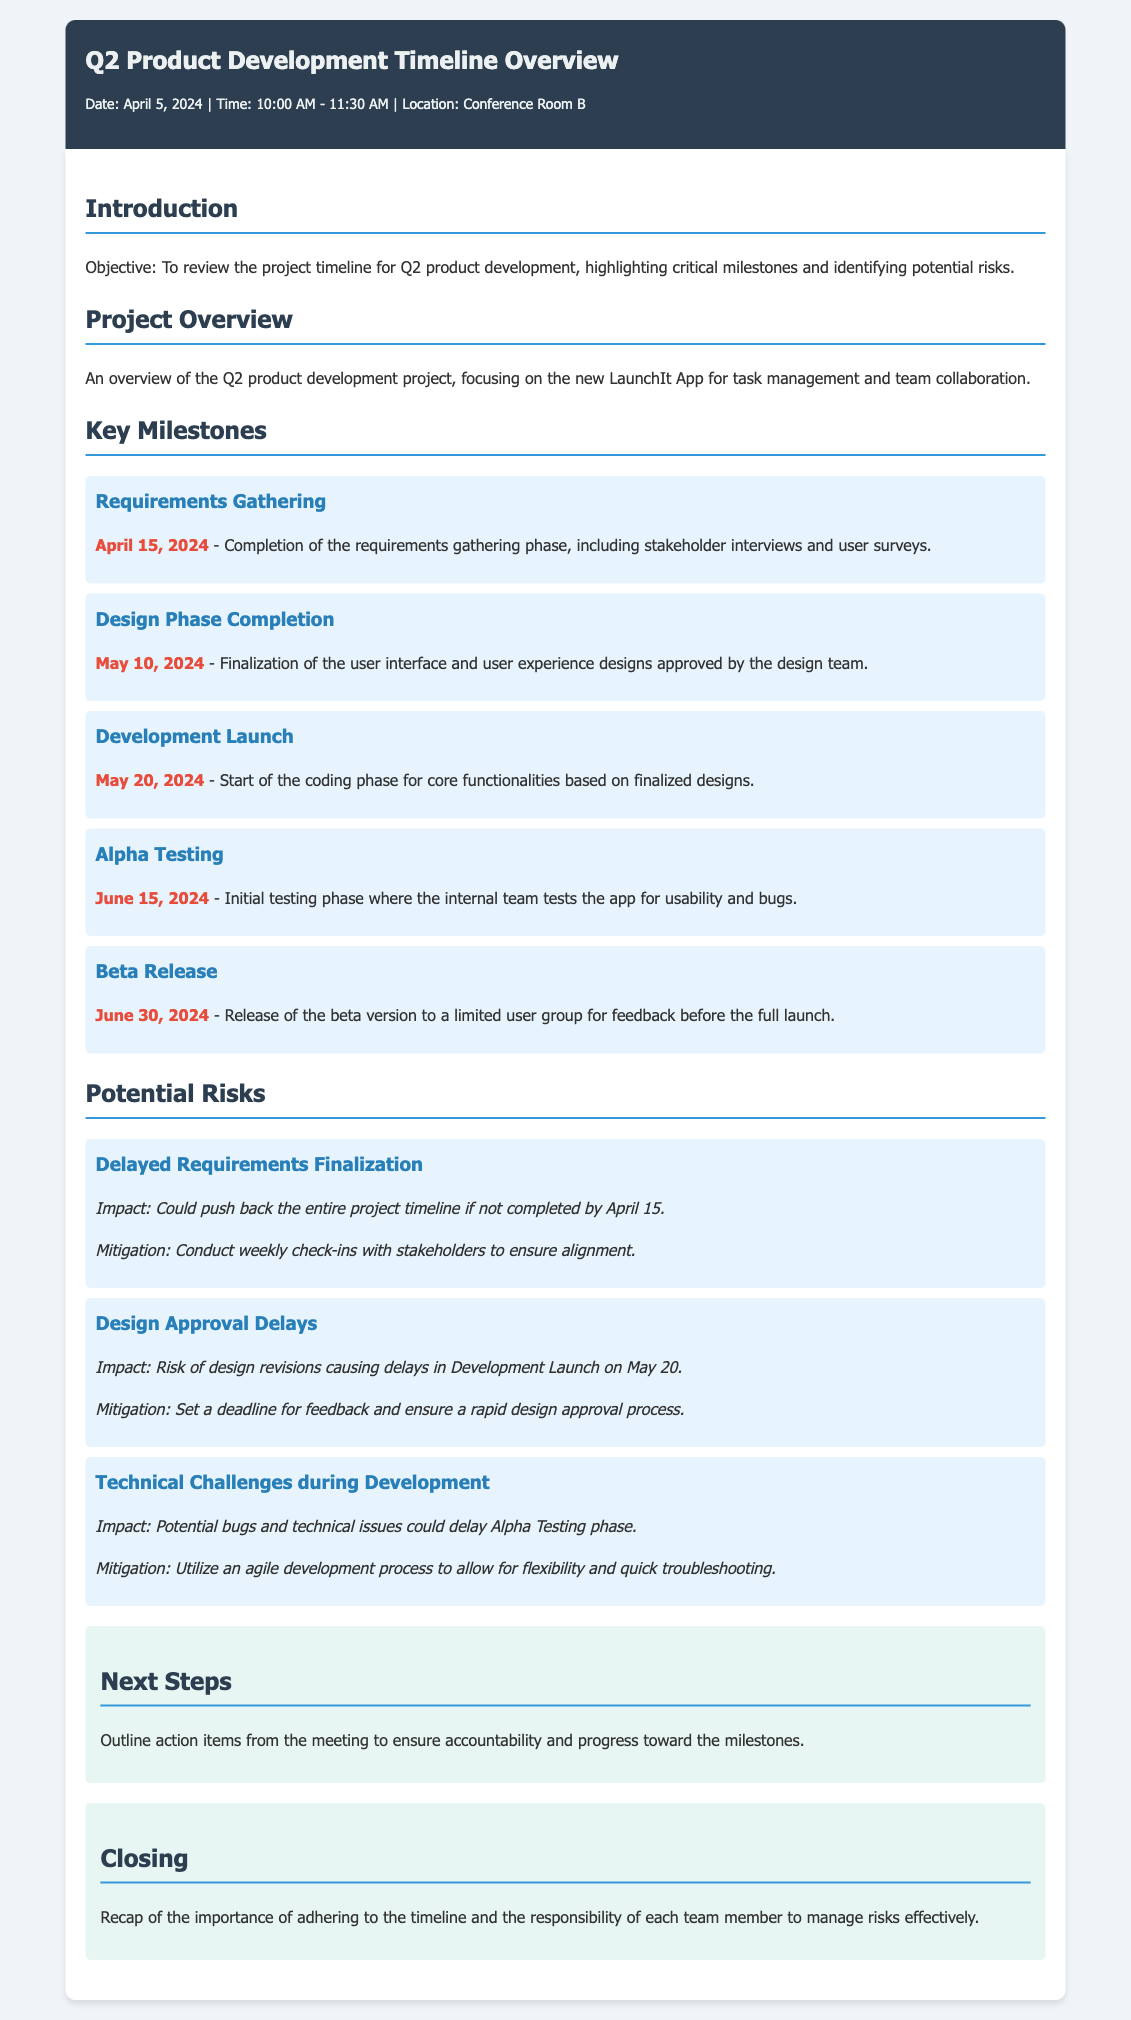What is the date of the meeting? The date of the meeting is specified in the meta-info section as April 5, 2024.
Answer: April 5, 2024 What is the name of the app being developed? The document mentions that the project focuses on developing the LaunchIt App for task management and team collaboration.
Answer: LaunchIt App What is the completion date for the Requirements Gathering phase? The completion date for the Requirements Gathering phase is mentioned as April 15, 2024.
Answer: April 15, 2024 What is the impact of delayed requirements finalization? The impact described for delayed requirements finalization could push back the entire project timeline if not completed by April 15.
Answer: Push back the entire project timeline How many key milestones are listed in the document? The document lists five key milestones in the Project Overview section.
Answer: Five What is the date for the Development Launch? The date for the Development Launch is mentioned as May 20, 2024.
Answer: May 20, 2024 What is the mitigation strategy for technical challenges during development? The mitigation strategy states to utilize an agile development process to allow for flexibility and quick troubleshooting.
Answer: Utilize an agile development process What phase follows the Beta Release in the project timeline? The document indicates that after the Beta Release, there is a recap in the Closing section but does not specify the next phase in the timeline.
Answer: Not specified 